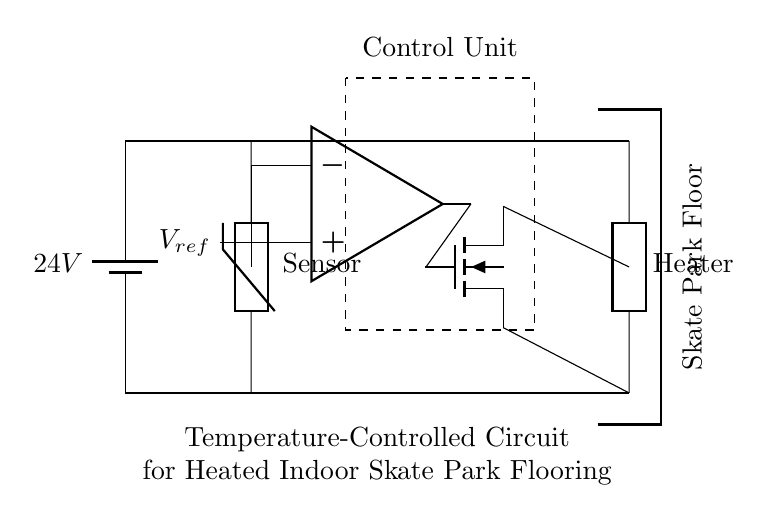What is the voltage of the power supply? The circuit shows a battery labeled 24V connected at the top, which indicates the voltage supply for the system.
Answer: 24V What component is used to sense temperature? The circuit has a component labeled as a thermistor, which is specifically designed to measure temperature changes.
Answer: Thermistor What type of switch is featured in this circuit? The circuit includes a MOSFET, which is indicated by the symbol for a field-effect transistor that controls the current to the heating element based on the signal from the op-amp.
Answer: MOSFET How many main sections are visible in the circuit? The circuit is divided into three main sections: the power supply, the control unit, and the heating system, as indicated by the separate components and their arrangements.
Answer: Three What condition triggers the heating element to activate? The activation of the heating element is based on the output from the op-amp comparing the thermistor reading against a reference voltage, which works to maintain the desired temperature.
Answer: Comparator output What is the primary purpose of this circuit? This circuit is designed to maintain a temperature-controlled environment for an indoor skate park flooring system to ensure an optimal skating surface.
Answer: Temperature control What is the load component in this circuit? The load, which requires power from the power supply and is controlled by the MOSFET, is labeled as the heater that raises the temperature of the floor.
Answer: Heater 